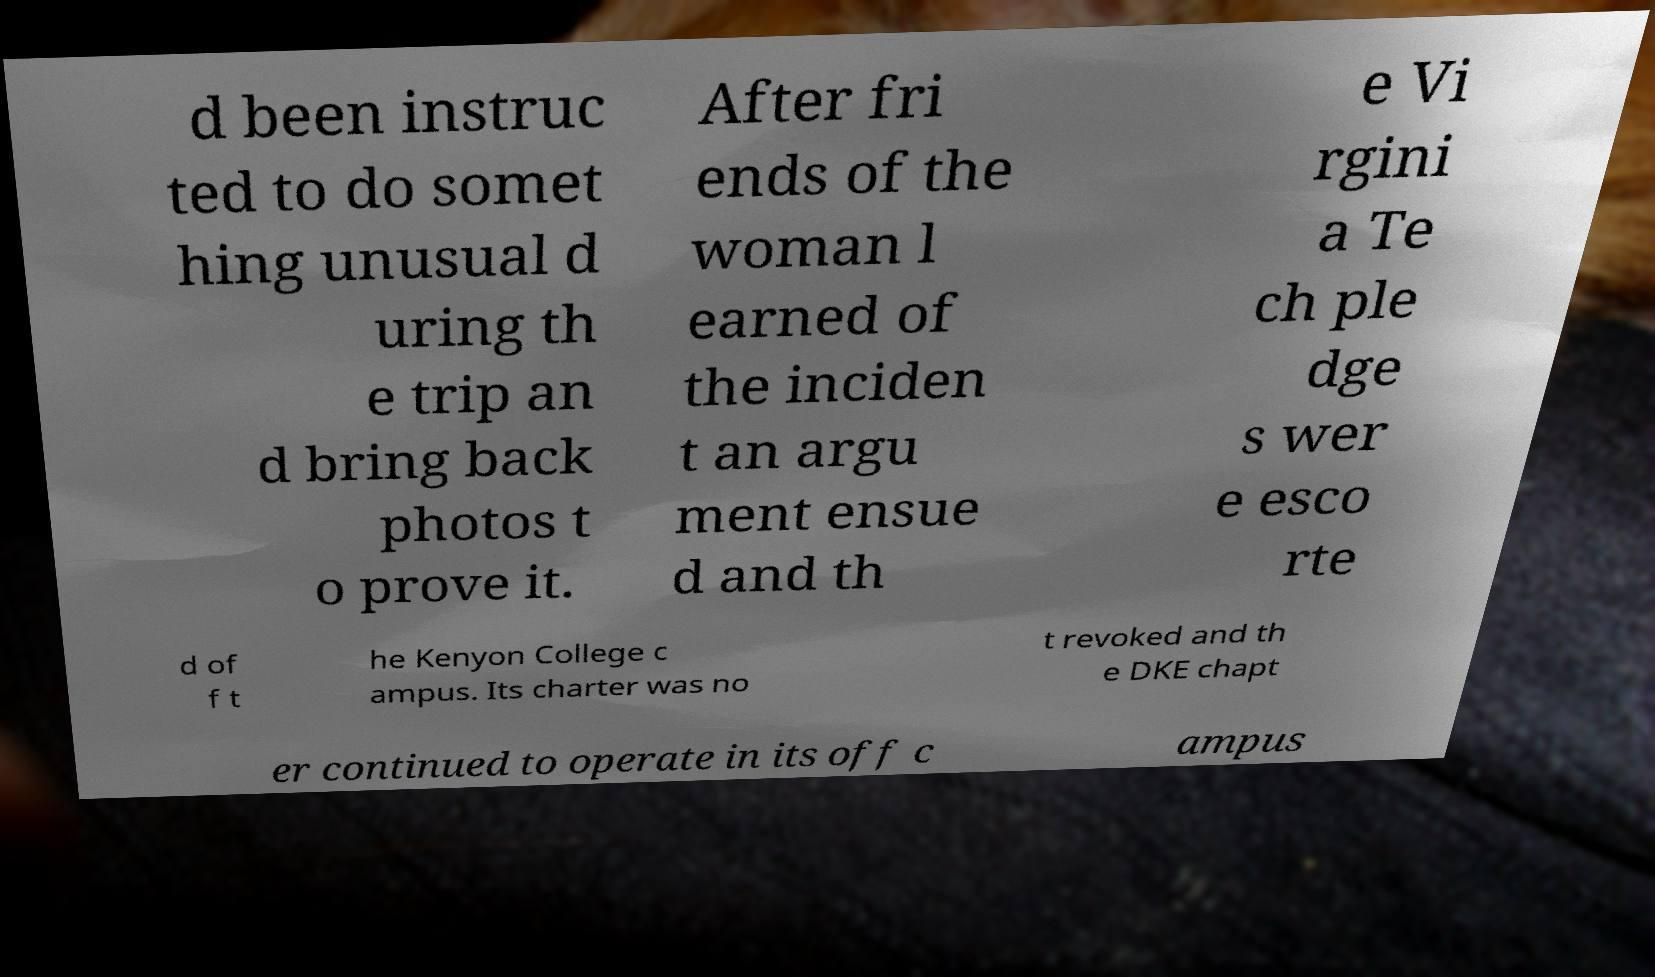Could you assist in decoding the text presented in this image and type it out clearly? d been instruc ted to do somet hing unusual d uring th e trip an d bring back photos t o prove it. After fri ends of the woman l earned of the inciden t an argu ment ensue d and th e Vi rgini a Te ch ple dge s wer e esco rte d of f t he Kenyon College c ampus. Its charter was no t revoked and th e DKE chapt er continued to operate in its off c ampus 